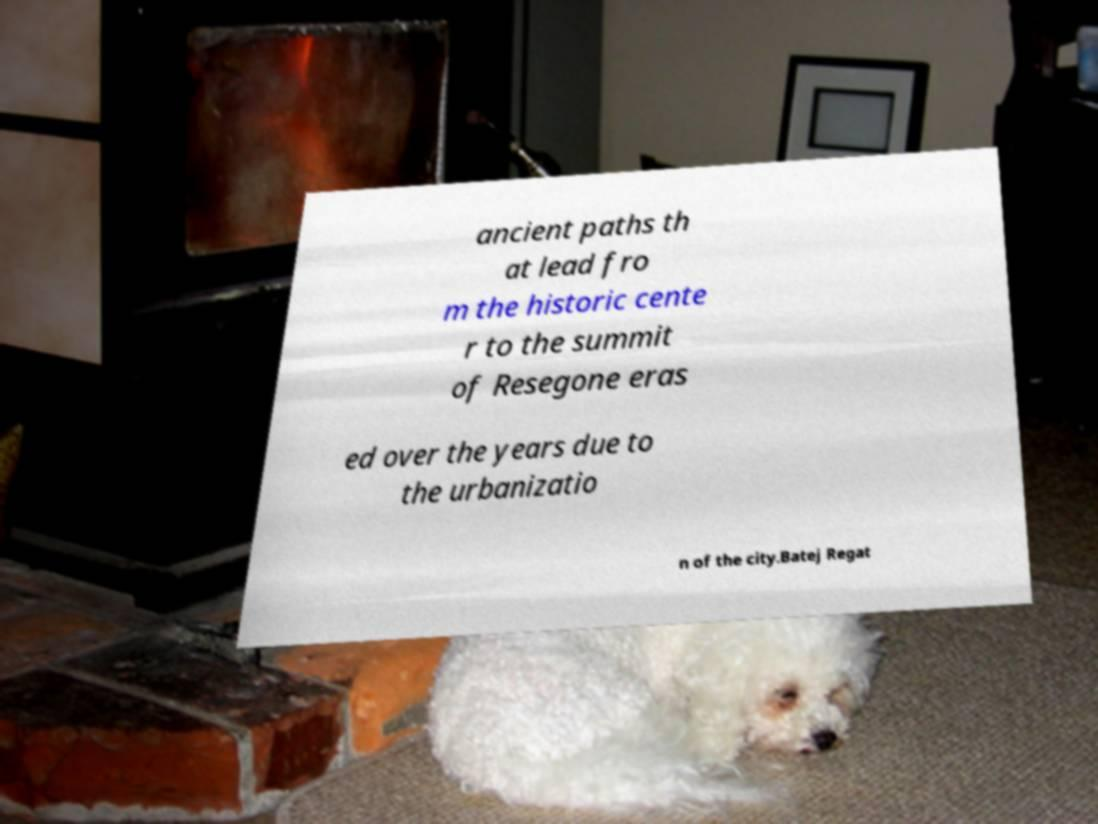Can you accurately transcribe the text from the provided image for me? ancient paths th at lead fro m the historic cente r to the summit of Resegone eras ed over the years due to the urbanizatio n of the city.Batej Regat 